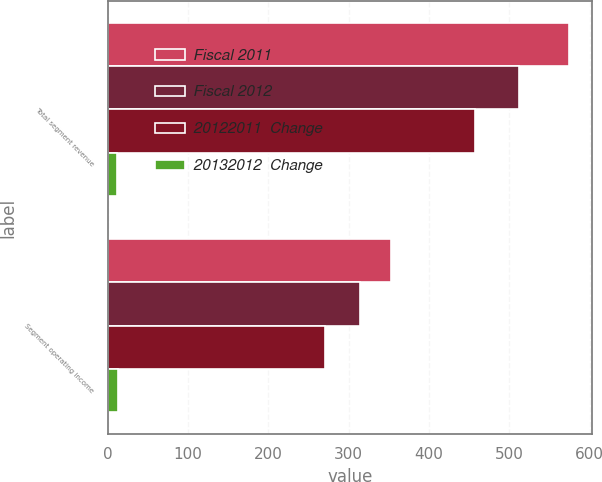Convert chart. <chart><loc_0><loc_0><loc_500><loc_500><stacked_bar_chart><ecel><fcel>Total segment revenue<fcel>Segment operating income<nl><fcel>Fiscal 2011<fcel>574<fcel>353<nl><fcel>Fiscal 2012<fcel>512<fcel>314<nl><fcel>20122011  Change<fcel>457<fcel>271<nl><fcel>20132012  Change<fcel>12<fcel>13<nl></chart> 